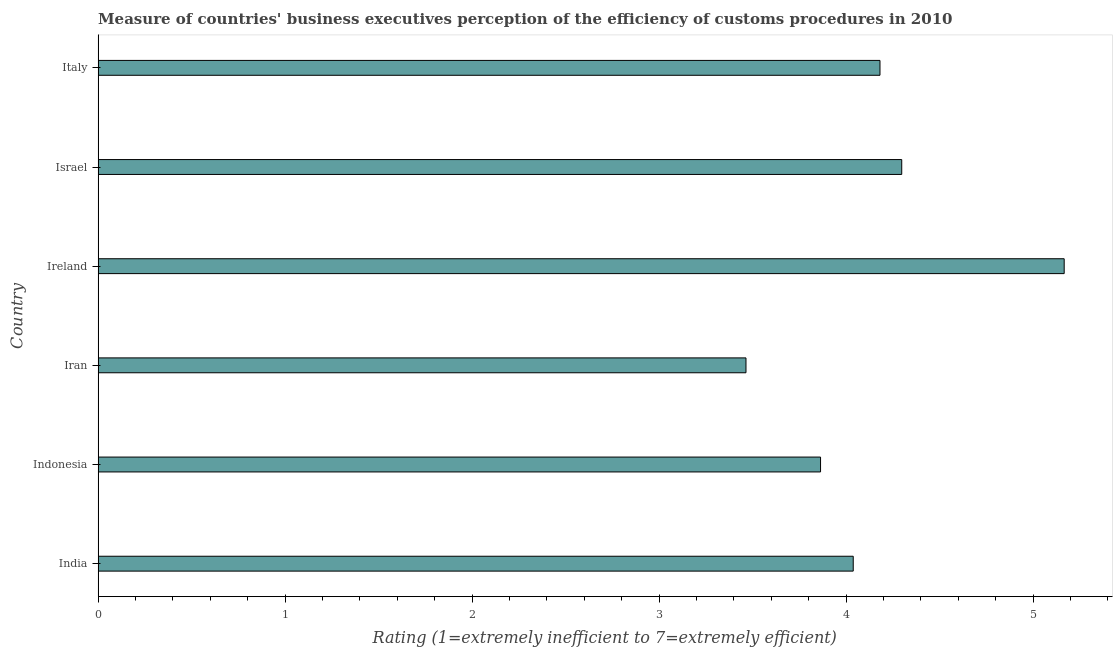What is the title of the graph?
Provide a short and direct response. Measure of countries' business executives perception of the efficiency of customs procedures in 2010. What is the label or title of the X-axis?
Give a very brief answer. Rating (1=extremely inefficient to 7=extremely efficient). What is the label or title of the Y-axis?
Make the answer very short. Country. What is the rating measuring burden of customs procedure in Israel?
Ensure brevity in your answer.  4.3. Across all countries, what is the maximum rating measuring burden of customs procedure?
Give a very brief answer. 5.17. Across all countries, what is the minimum rating measuring burden of customs procedure?
Your answer should be very brief. 3.46. In which country was the rating measuring burden of customs procedure maximum?
Your response must be concise. Ireland. In which country was the rating measuring burden of customs procedure minimum?
Provide a succinct answer. Iran. What is the sum of the rating measuring burden of customs procedure?
Provide a short and direct response. 25.01. What is the difference between the rating measuring burden of customs procedure in India and Indonesia?
Offer a terse response. 0.17. What is the average rating measuring burden of customs procedure per country?
Your answer should be compact. 4.17. What is the median rating measuring burden of customs procedure?
Ensure brevity in your answer.  4.11. What is the ratio of the rating measuring burden of customs procedure in Iran to that in Italy?
Offer a very short reply. 0.83. Is the rating measuring burden of customs procedure in Ireland less than that in Italy?
Offer a terse response. No. What is the difference between the highest and the second highest rating measuring burden of customs procedure?
Provide a succinct answer. 0.87. Is the sum of the rating measuring burden of customs procedure in Iran and Italy greater than the maximum rating measuring burden of customs procedure across all countries?
Provide a short and direct response. Yes. What is the difference between the highest and the lowest rating measuring burden of customs procedure?
Give a very brief answer. 1.7. In how many countries, is the rating measuring burden of customs procedure greater than the average rating measuring burden of customs procedure taken over all countries?
Your answer should be very brief. 3. Are all the bars in the graph horizontal?
Ensure brevity in your answer.  Yes. How many countries are there in the graph?
Your answer should be compact. 6. Are the values on the major ticks of X-axis written in scientific E-notation?
Provide a short and direct response. No. What is the Rating (1=extremely inefficient to 7=extremely efficient) of India?
Provide a short and direct response. 4.04. What is the Rating (1=extremely inefficient to 7=extremely efficient) in Indonesia?
Your response must be concise. 3.86. What is the Rating (1=extremely inefficient to 7=extremely efficient) in Iran?
Give a very brief answer. 3.46. What is the Rating (1=extremely inefficient to 7=extremely efficient) of Ireland?
Provide a succinct answer. 5.17. What is the Rating (1=extremely inefficient to 7=extremely efficient) in Israel?
Keep it short and to the point. 4.3. What is the Rating (1=extremely inefficient to 7=extremely efficient) in Italy?
Offer a terse response. 4.18. What is the difference between the Rating (1=extremely inefficient to 7=extremely efficient) in India and Indonesia?
Your answer should be compact. 0.17. What is the difference between the Rating (1=extremely inefficient to 7=extremely efficient) in India and Iran?
Your answer should be compact. 0.57. What is the difference between the Rating (1=extremely inefficient to 7=extremely efficient) in India and Ireland?
Give a very brief answer. -1.13. What is the difference between the Rating (1=extremely inefficient to 7=extremely efficient) in India and Israel?
Offer a very short reply. -0.26. What is the difference between the Rating (1=extremely inefficient to 7=extremely efficient) in India and Italy?
Offer a very short reply. -0.14. What is the difference between the Rating (1=extremely inefficient to 7=extremely efficient) in Indonesia and Iran?
Your response must be concise. 0.4. What is the difference between the Rating (1=extremely inefficient to 7=extremely efficient) in Indonesia and Ireland?
Keep it short and to the point. -1.3. What is the difference between the Rating (1=extremely inefficient to 7=extremely efficient) in Indonesia and Israel?
Offer a terse response. -0.43. What is the difference between the Rating (1=extremely inefficient to 7=extremely efficient) in Indonesia and Italy?
Ensure brevity in your answer.  -0.32. What is the difference between the Rating (1=extremely inefficient to 7=extremely efficient) in Iran and Ireland?
Provide a short and direct response. -1.7. What is the difference between the Rating (1=extremely inefficient to 7=extremely efficient) in Iran and Israel?
Your answer should be compact. -0.83. What is the difference between the Rating (1=extremely inefficient to 7=extremely efficient) in Iran and Italy?
Provide a succinct answer. -0.72. What is the difference between the Rating (1=extremely inefficient to 7=extremely efficient) in Ireland and Israel?
Ensure brevity in your answer.  0.87. What is the difference between the Rating (1=extremely inefficient to 7=extremely efficient) in Ireland and Italy?
Make the answer very short. 0.99. What is the difference between the Rating (1=extremely inefficient to 7=extremely efficient) in Israel and Italy?
Offer a terse response. 0.12. What is the ratio of the Rating (1=extremely inefficient to 7=extremely efficient) in India to that in Indonesia?
Ensure brevity in your answer.  1.04. What is the ratio of the Rating (1=extremely inefficient to 7=extremely efficient) in India to that in Iran?
Keep it short and to the point. 1.17. What is the ratio of the Rating (1=extremely inefficient to 7=extremely efficient) in India to that in Ireland?
Your response must be concise. 0.78. What is the ratio of the Rating (1=extremely inefficient to 7=extremely efficient) in India to that in Israel?
Keep it short and to the point. 0.94. What is the ratio of the Rating (1=extremely inefficient to 7=extremely efficient) in Indonesia to that in Iran?
Provide a succinct answer. 1.11. What is the ratio of the Rating (1=extremely inefficient to 7=extremely efficient) in Indonesia to that in Ireland?
Offer a very short reply. 0.75. What is the ratio of the Rating (1=extremely inefficient to 7=extremely efficient) in Indonesia to that in Israel?
Make the answer very short. 0.9. What is the ratio of the Rating (1=extremely inefficient to 7=extremely efficient) in Indonesia to that in Italy?
Your response must be concise. 0.92. What is the ratio of the Rating (1=extremely inefficient to 7=extremely efficient) in Iran to that in Ireland?
Keep it short and to the point. 0.67. What is the ratio of the Rating (1=extremely inefficient to 7=extremely efficient) in Iran to that in Israel?
Ensure brevity in your answer.  0.81. What is the ratio of the Rating (1=extremely inefficient to 7=extremely efficient) in Iran to that in Italy?
Make the answer very short. 0.83. What is the ratio of the Rating (1=extremely inefficient to 7=extremely efficient) in Ireland to that in Israel?
Provide a short and direct response. 1.2. What is the ratio of the Rating (1=extremely inefficient to 7=extremely efficient) in Ireland to that in Italy?
Provide a succinct answer. 1.24. What is the ratio of the Rating (1=extremely inefficient to 7=extremely efficient) in Israel to that in Italy?
Give a very brief answer. 1.03. 